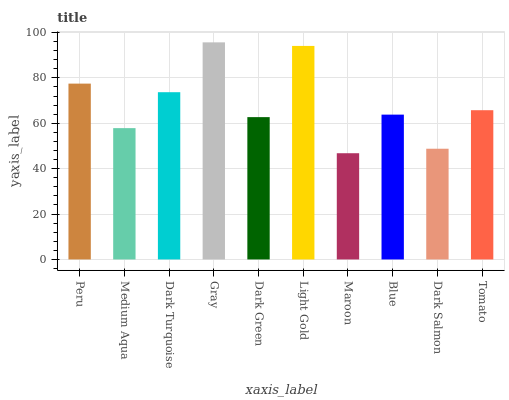Is Maroon the minimum?
Answer yes or no. Yes. Is Gray the maximum?
Answer yes or no. Yes. Is Medium Aqua the minimum?
Answer yes or no. No. Is Medium Aqua the maximum?
Answer yes or no. No. Is Peru greater than Medium Aqua?
Answer yes or no. Yes. Is Medium Aqua less than Peru?
Answer yes or no. Yes. Is Medium Aqua greater than Peru?
Answer yes or no. No. Is Peru less than Medium Aqua?
Answer yes or no. No. Is Tomato the high median?
Answer yes or no. Yes. Is Blue the low median?
Answer yes or no. Yes. Is Dark Turquoise the high median?
Answer yes or no. No. Is Dark Green the low median?
Answer yes or no. No. 